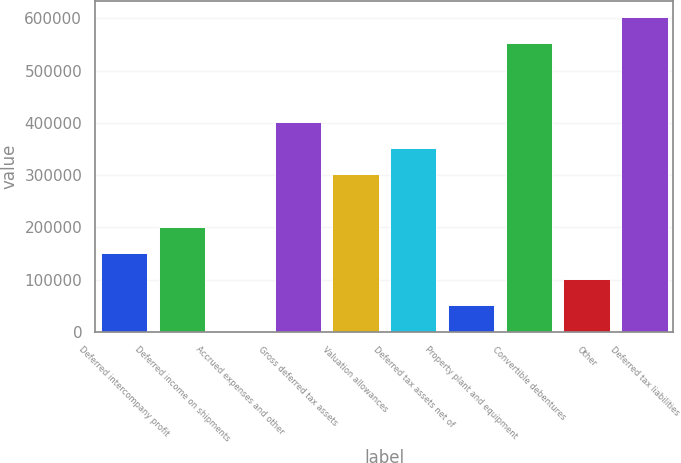<chart> <loc_0><loc_0><loc_500><loc_500><bar_chart><fcel>Deferred intercompany profit<fcel>Deferred income on shipments<fcel>Accrued expenses and other<fcel>Gross deferred tax assets<fcel>Valuation allowances<fcel>Deferred tax assets net of<fcel>Property plant and equipment<fcel>Convertible debentures<fcel>Other<fcel>Deferred tax liabilities<nl><fcel>151163<fcel>201327<fcel>671<fcel>401982<fcel>301654<fcel>351818<fcel>50834.9<fcel>552474<fcel>100999<fcel>602638<nl></chart> 